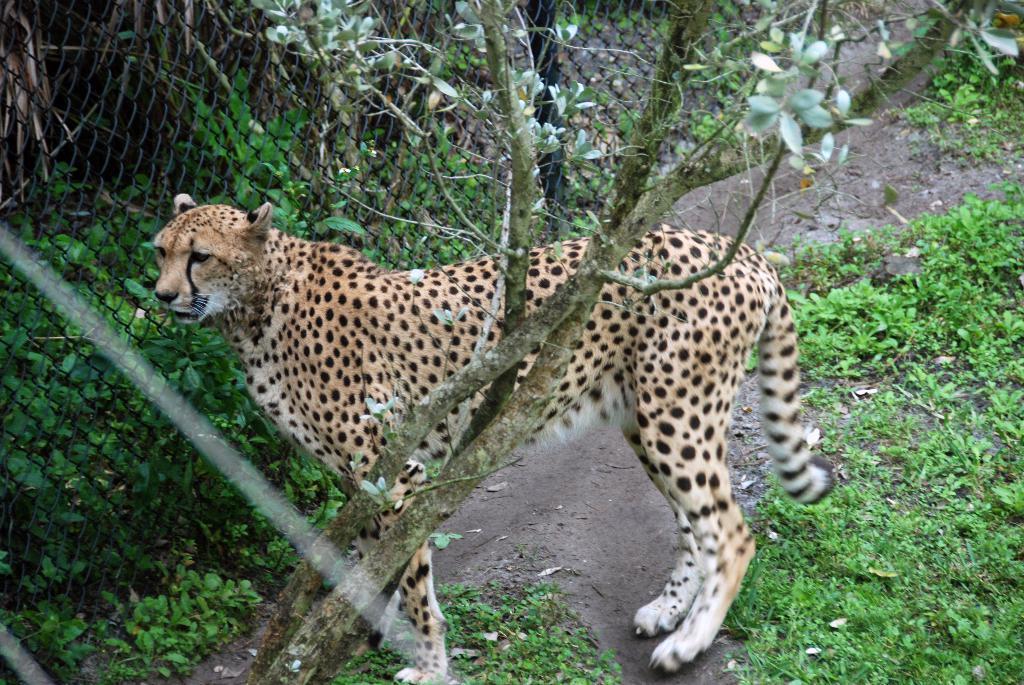How would you summarize this image in a sentence or two? In this picture there is a cheetah standing. In the foreground there is a tree. At the back there are plants behind the fence. At the bottom there is ground and there are plants. 